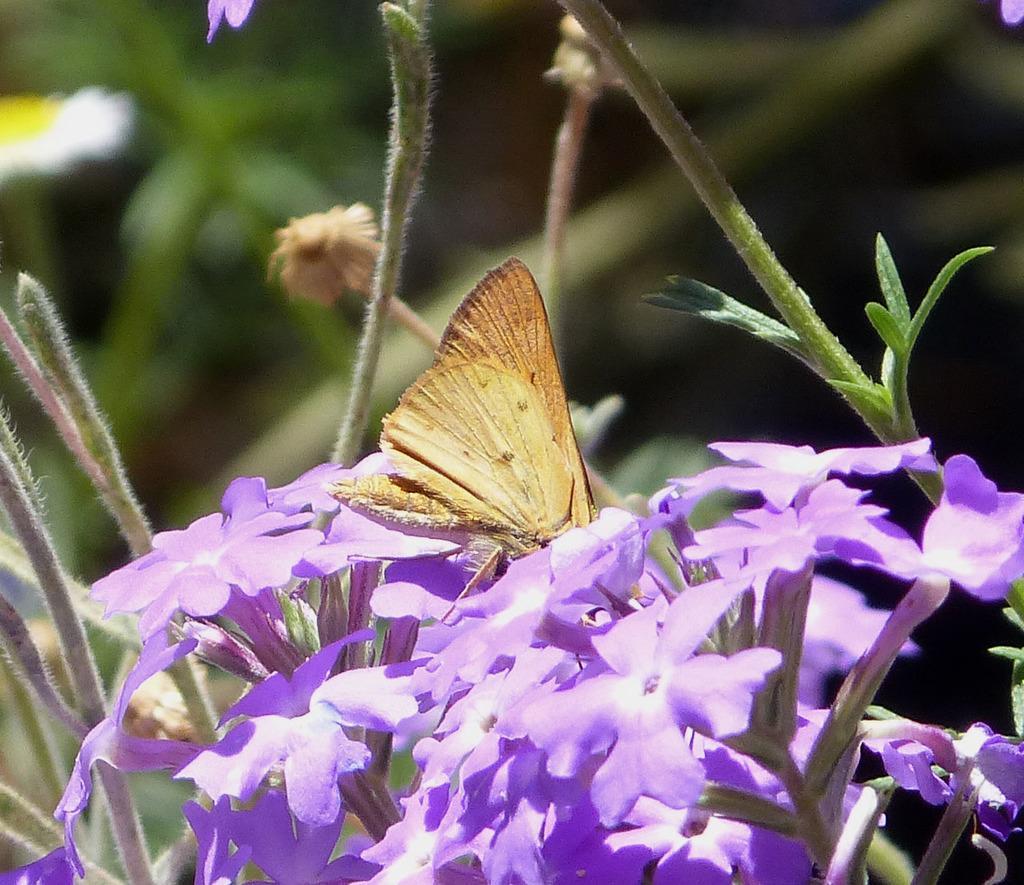How would you summarize this image in a sentence or two? It is a butterfly on the lavender flowers. 